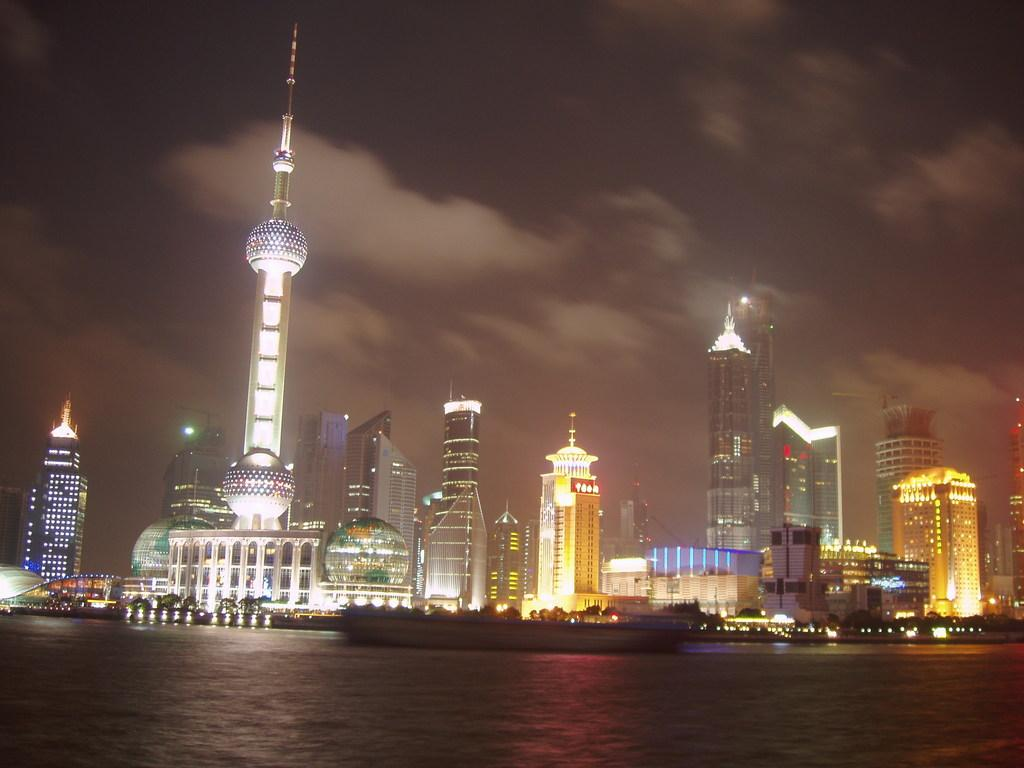What is the main subject of the image? The main subject of the image is water. What else can be seen in the water? There are boats in the image. What can be seen in the distance? There are buildings in the background of the image. How would you describe the sky in the image? The sky is dark in the background of the image. What type of fruit is floating in the water in the image? There is no fruit present in the image; it only features water, boats, buildings, and a dark sky. 